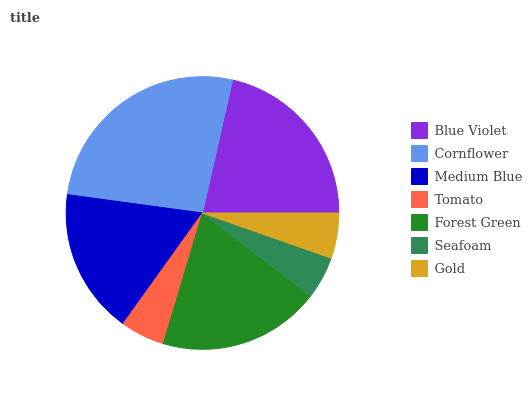Is Seafoam the minimum?
Answer yes or no. Yes. Is Cornflower the maximum?
Answer yes or no. Yes. Is Medium Blue the minimum?
Answer yes or no. No. Is Medium Blue the maximum?
Answer yes or no. No. Is Cornflower greater than Medium Blue?
Answer yes or no. Yes. Is Medium Blue less than Cornflower?
Answer yes or no. Yes. Is Medium Blue greater than Cornflower?
Answer yes or no. No. Is Cornflower less than Medium Blue?
Answer yes or no. No. Is Medium Blue the high median?
Answer yes or no. Yes. Is Medium Blue the low median?
Answer yes or no. Yes. Is Cornflower the high median?
Answer yes or no. No. Is Gold the low median?
Answer yes or no. No. 